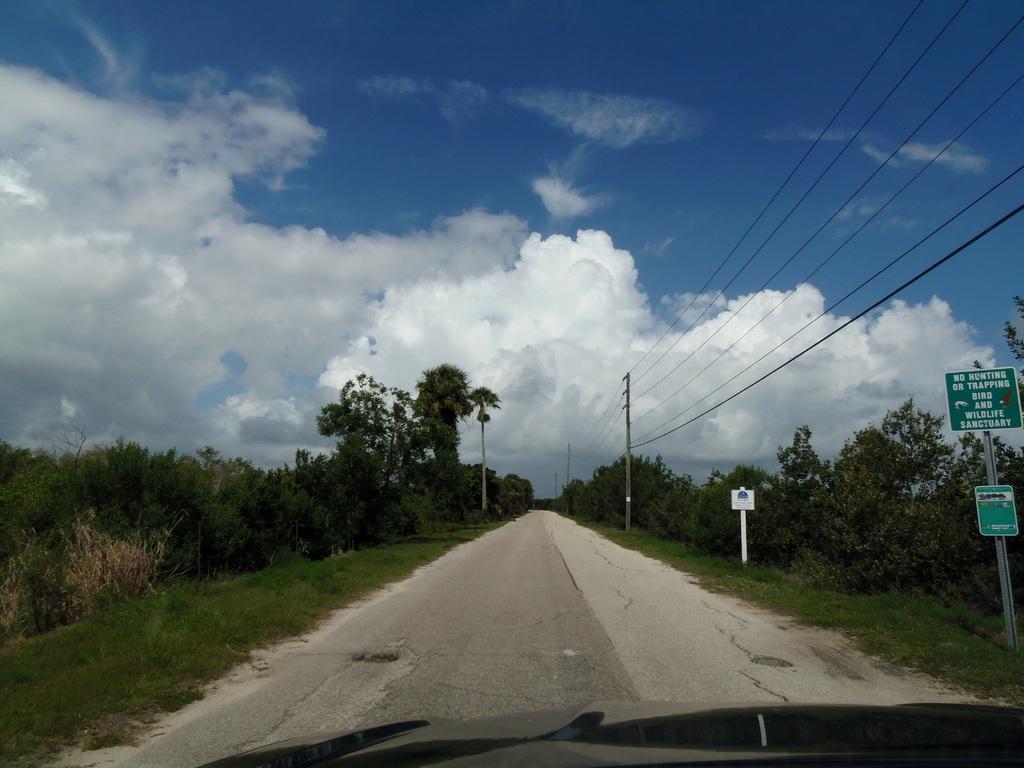Please provide a concise description of this image. In this image we can see a road, at the left and right side of the image there are some trees, at the right side of the image there are poles, signage boards, wires and at the top of the image there is clear sky. 